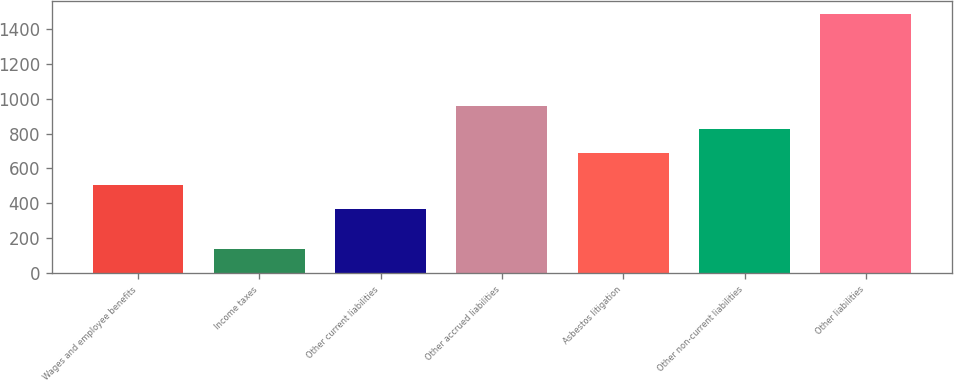Convert chart. <chart><loc_0><loc_0><loc_500><loc_500><bar_chart><fcel>Wages and employee benefits<fcel>Income taxes<fcel>Other current liabilities<fcel>Other accrued liabilities<fcel>Asbestos litigation<fcel>Other non-current liabilities<fcel>Other liabilities<nl><fcel>504.4<fcel>139<fcel>370<fcel>958.8<fcel>690<fcel>824.4<fcel>1483<nl></chart> 